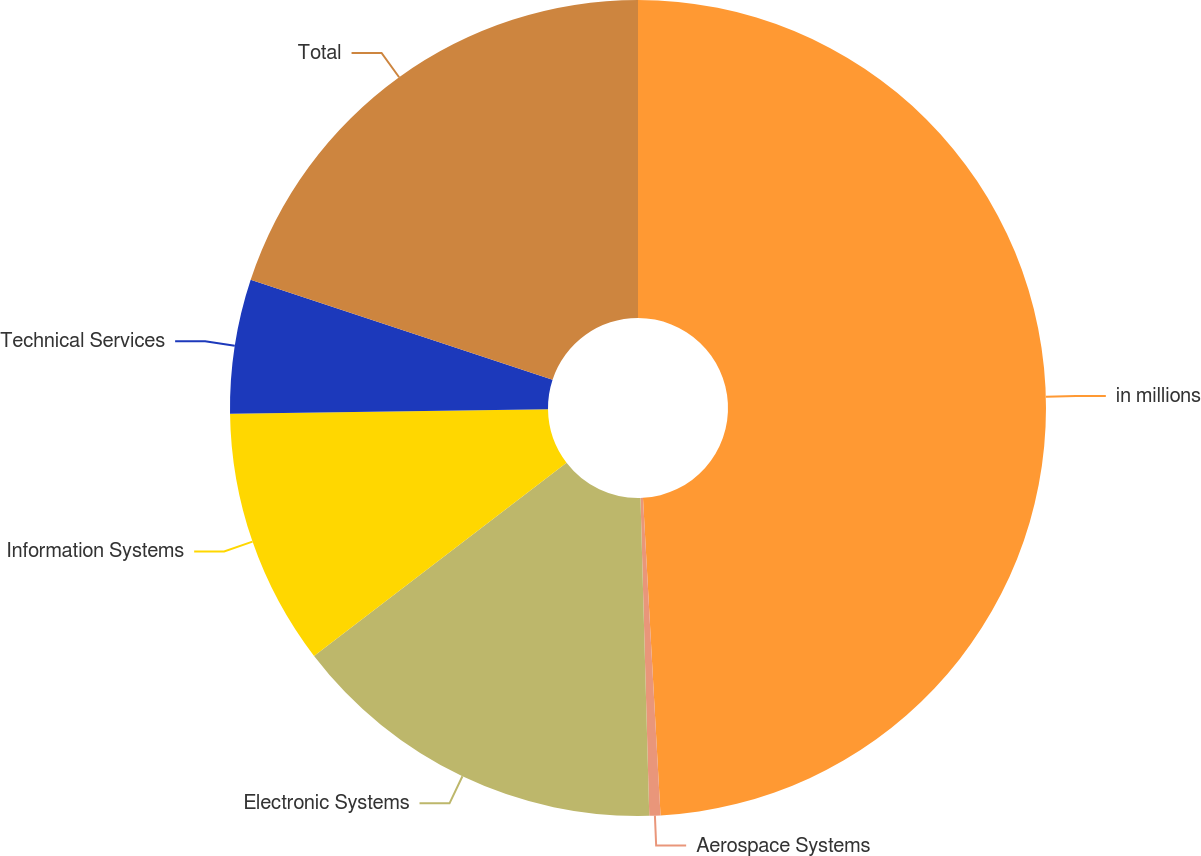Convert chart. <chart><loc_0><loc_0><loc_500><loc_500><pie_chart><fcel>in millions<fcel>Aerospace Systems<fcel>Electronic Systems<fcel>Information Systems<fcel>Technical Services<fcel>Total<nl><fcel>49.12%<fcel>0.44%<fcel>15.04%<fcel>10.18%<fcel>5.31%<fcel>19.91%<nl></chart> 